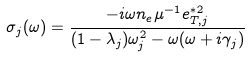Convert formula to latex. <formula><loc_0><loc_0><loc_500><loc_500>\sigma _ { j } ( \omega ) = \frac { - i \omega n _ { e } \mu ^ { - 1 } e _ { T , j } ^ { * 2 } } { ( 1 - \lambda _ { j } ) \omega _ { j } ^ { 2 } - \omega ( \omega + i \gamma _ { j } ) }</formula> 